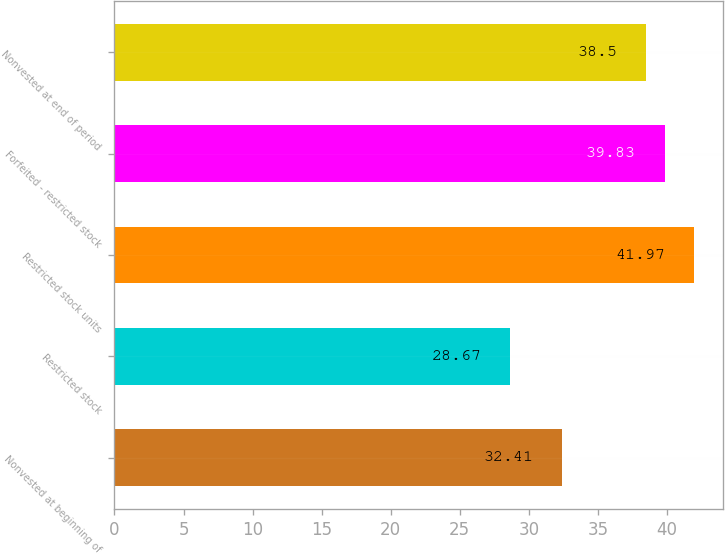<chart> <loc_0><loc_0><loc_500><loc_500><bar_chart><fcel>Nonvested at beginning of<fcel>Restricted stock<fcel>Restricted stock units<fcel>Forfeited - restricted stock<fcel>Nonvested at end of period<nl><fcel>32.41<fcel>28.67<fcel>41.97<fcel>39.83<fcel>38.5<nl></chart> 